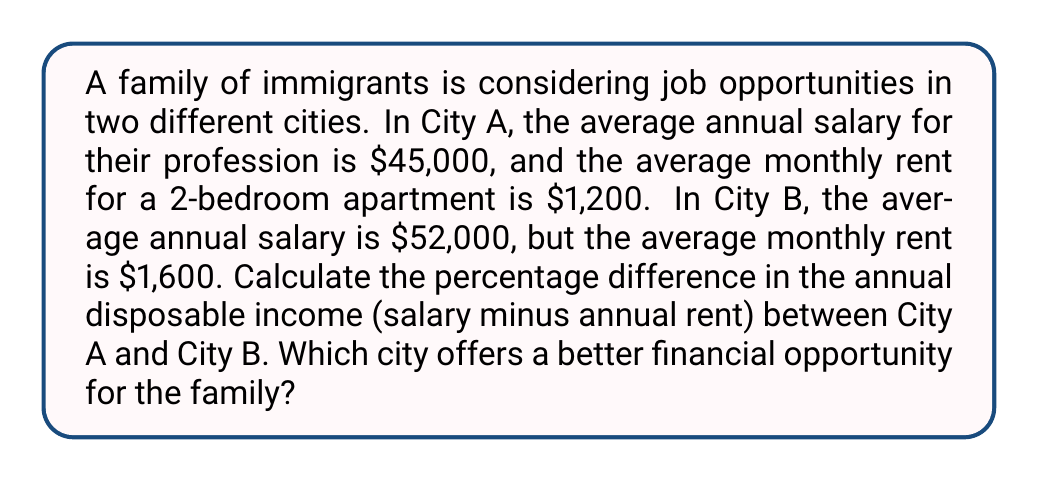Solve this math problem. Let's approach this problem step by step:

1. Calculate the annual rent for both cities:
   City A: $1,200 × 12 = $14,400
   City B: $1,600 × 12 = $19,200

2. Calculate the annual disposable income for both cities:
   City A: $45,000 - $14,400 = $30,600
   City B: $52,000 - $19,200 = $32,800

3. To calculate the percentage difference, we use the formula:
   $$ \text{Percentage Difference} = \frac{|\text{Value}_1 - \text{Value}_2|}{\frac{(\text{Value}_1 + \text{Value}_2)}{2}} \times 100\% $$

4. Plugging in our values:
   $$ \text{Percentage Difference} = \frac{|32,800 - 30,600|}{\frac{(32,800 + 30,600)}{2}} \times 100\% $$

5. Simplifying:
   $$ \text{Percentage Difference} = \frac{2,200}{31,700} \times 100\% $$

6. Calculating:
   $$ \text{Percentage Difference} \approx 6.94\% $$

7. To determine which city offers a better financial opportunity, we compare the disposable incomes:
   City B ($32,800) > City A ($30,600)

Therefore, City B offers a better financial opportunity for the family, with approximately 6.94% higher disposable income.
Answer: The percentage difference in annual disposable income between City A and City B is approximately 6.94%. City B offers a better financial opportunity for the immigrant family. 